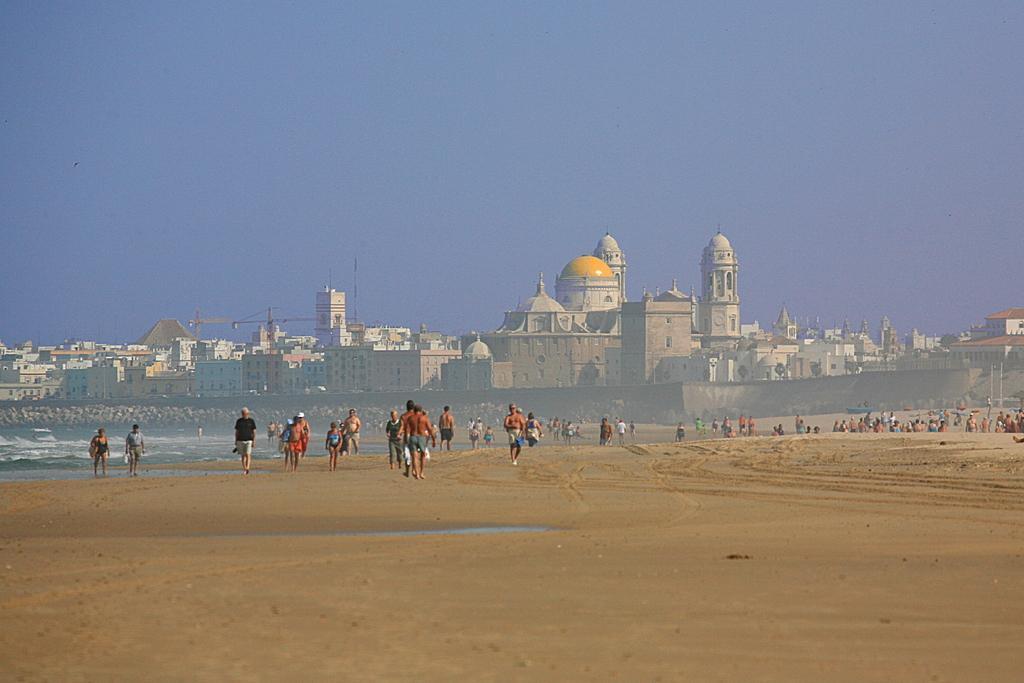How would you summarize this image in a sentence or two? In this image there are buildings and we can see people. There is water. In the background there is sky and we can see a wall. 